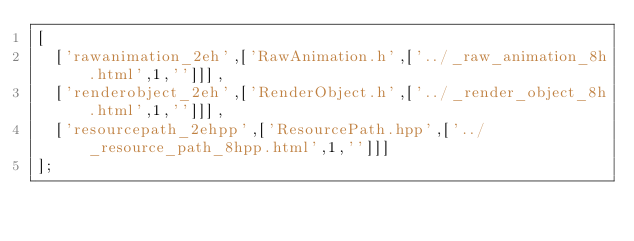Convert code to text. <code><loc_0><loc_0><loc_500><loc_500><_JavaScript_>[
  ['rawanimation_2eh',['RawAnimation.h',['../_raw_animation_8h.html',1,'']]],
  ['renderobject_2eh',['RenderObject.h',['../_render_object_8h.html',1,'']]],
  ['resourcepath_2ehpp',['ResourcePath.hpp',['../_resource_path_8hpp.html',1,'']]]
];
</code> 